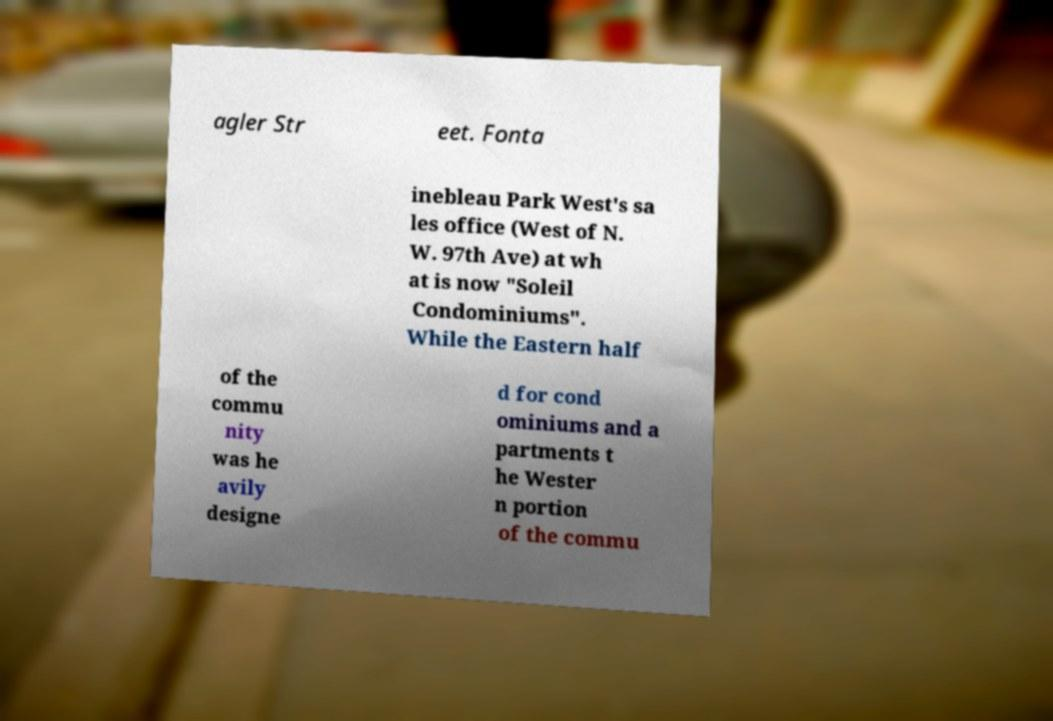Can you read and provide the text displayed in the image?This photo seems to have some interesting text. Can you extract and type it out for me? agler Str eet. Fonta inebleau Park West's sa les office (West of N. W. 97th Ave) at wh at is now "Soleil Condominiums". While the Eastern half of the commu nity was he avily designe d for cond ominiums and a partments t he Wester n portion of the commu 